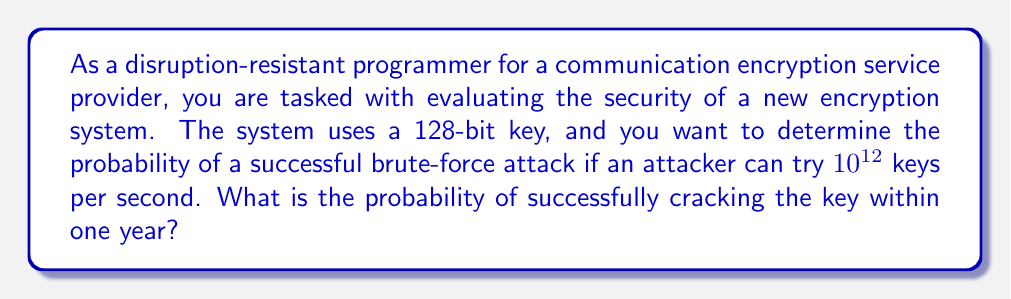Solve this math problem. To solve this problem, we need to follow these steps:

1. Calculate the total number of possible keys:
   $$N = 2^{128}$$

2. Calculate the number of keys that can be tested in one year:
   $$\text{Keys per second} = 10^{12}$$
   $$\text{Seconds in a year} = 365 \times 24 \times 60 \times 60 = 31,536,000$$
   $$\text{Keys tested in a year} = 10^{12} \times 31,536,000 = 3.1536 \times 10^{19}$$

3. Calculate the probability of success:
   The probability of success is the number of keys tested divided by the total number of possible keys.
   
   $$P(\text{success}) = \frac{\text{Keys tested in a year}}{N} = \frac{3.1536 \times 10^{19}}{2^{128}}$$

4. Simplify the calculation:
   $$P(\text{success}) = \frac{3.1536 \times 10^{19}}{2^{128}} \approx \frac{3.1536 \times 10^{19}}{3.4028 \times 10^{38}}$$

5. Perform the division:
   $$P(\text{success}) \approx 9.2676 \times 10^{-20}$$

This extremely small probability demonstrates the strength of a 128-bit encryption key against brute-force attacks.
Answer: $9.2676 \times 10^{-20}$ 